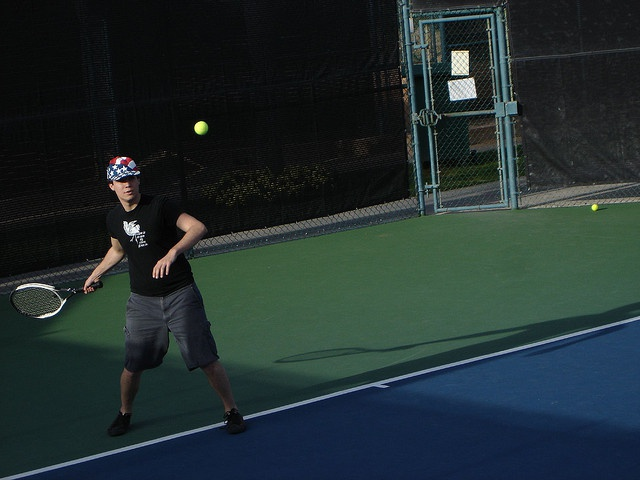Describe the objects in this image and their specific colors. I can see people in black, gray, and darkgreen tones, tennis racket in black, gray, and ivory tones, sports ball in black, khaki, and green tones, and sports ball in black, yellow, olive, and khaki tones in this image. 